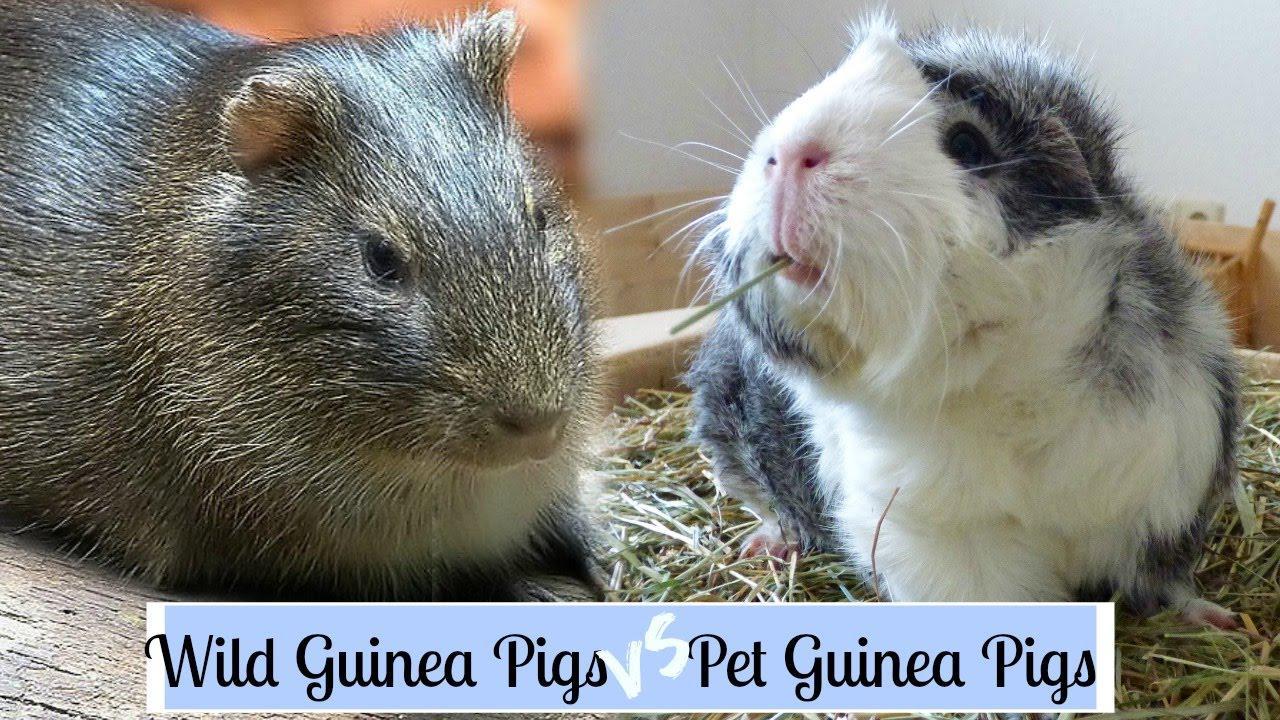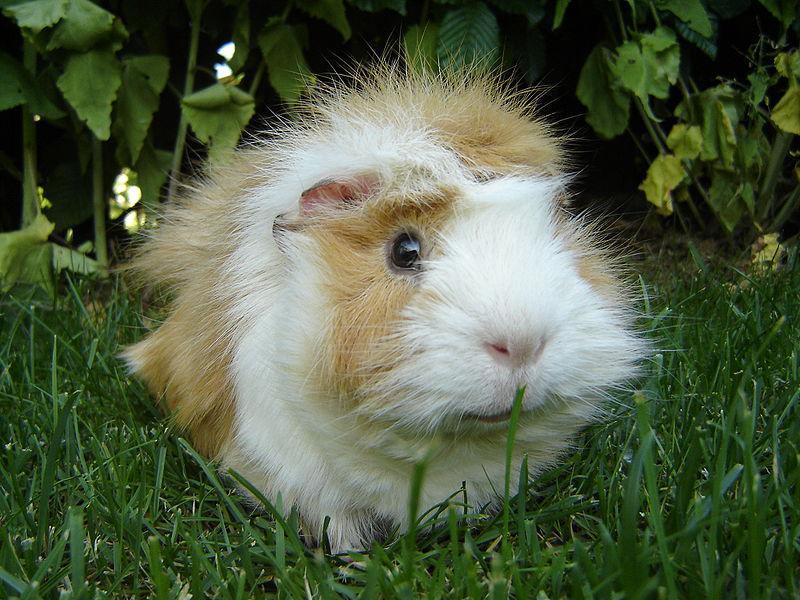The first image is the image on the left, the second image is the image on the right. Assess this claim about the two images: "An image shows one guinea pig standing in green grass.". Correct or not? Answer yes or no. Yes. The first image is the image on the left, the second image is the image on the right. Assess this claim about the two images: "One of the rodents is sitting still in the green grass.". Correct or not? Answer yes or no. Yes. 